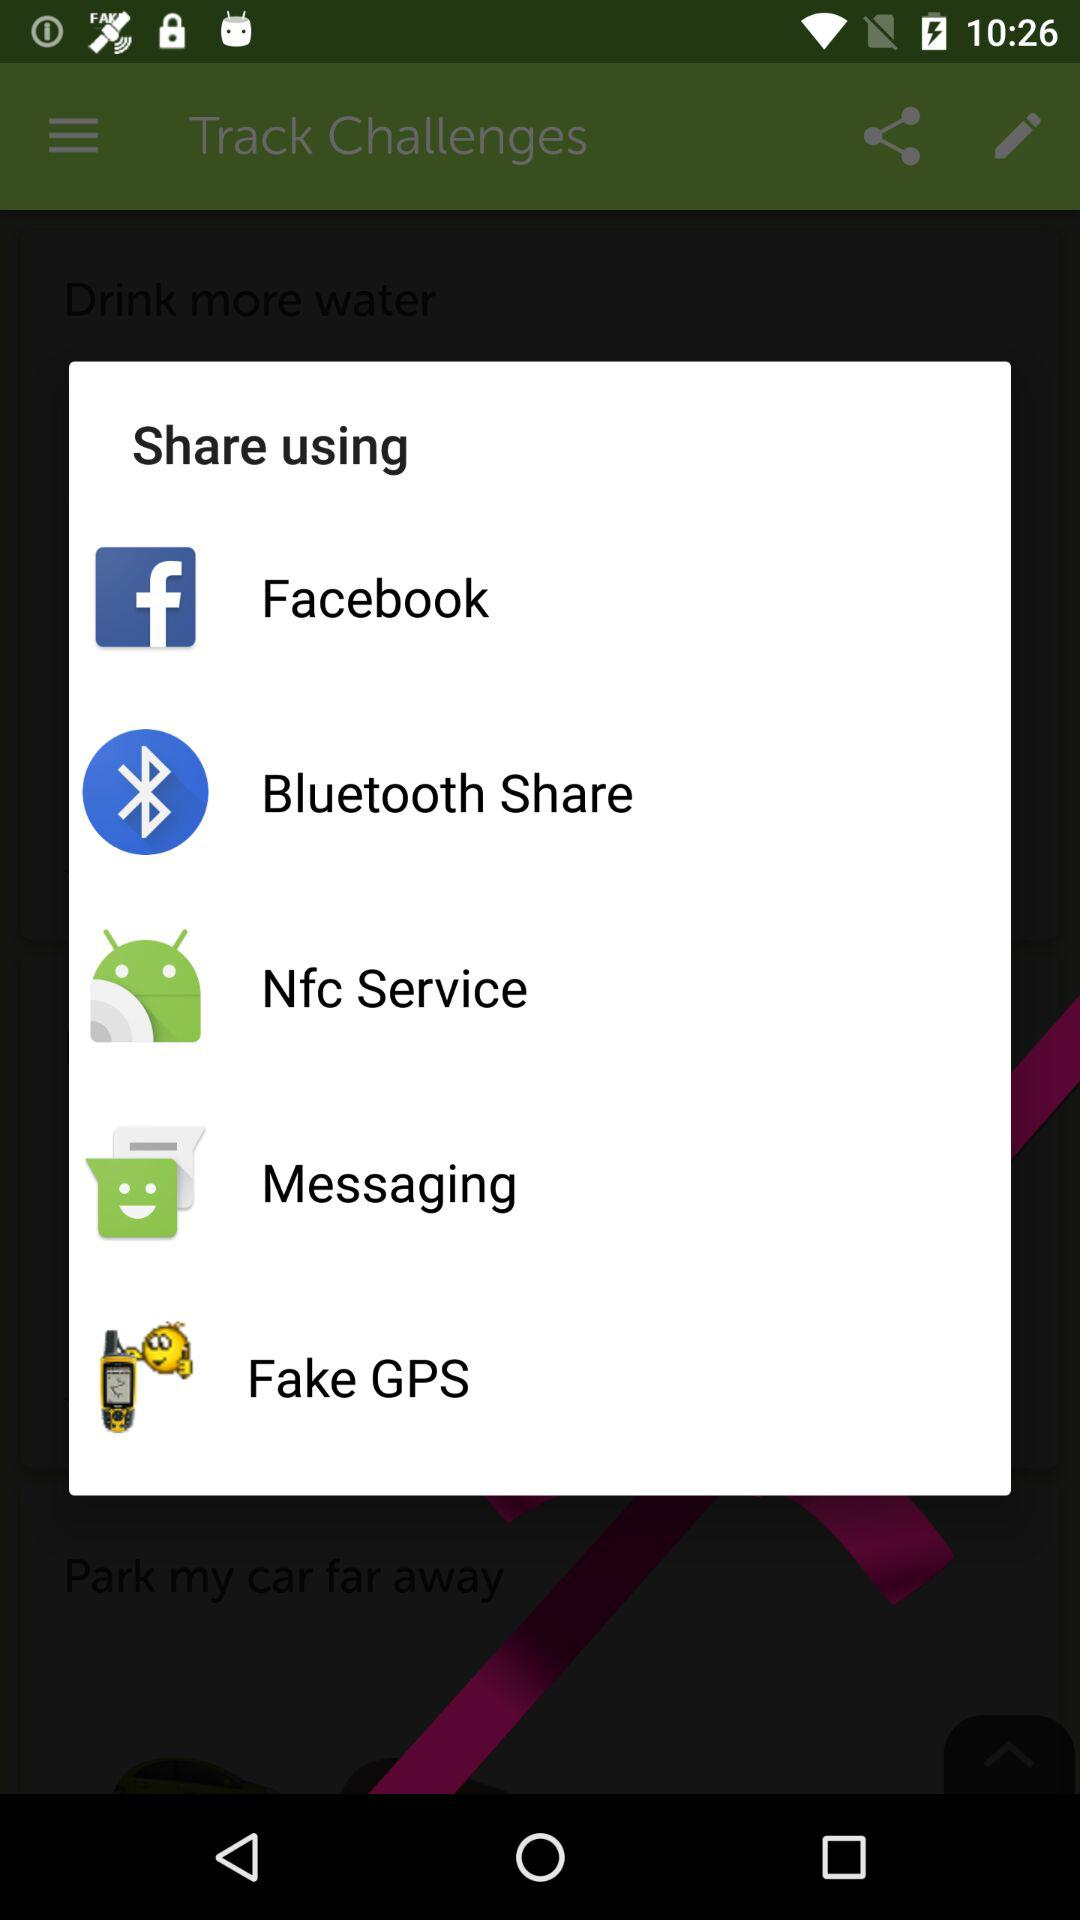What applications can I use to share the content? The applications are "Facebook", "Bluetooth Share", "Nfc Service", "Messaging" and "Fake GPS". 